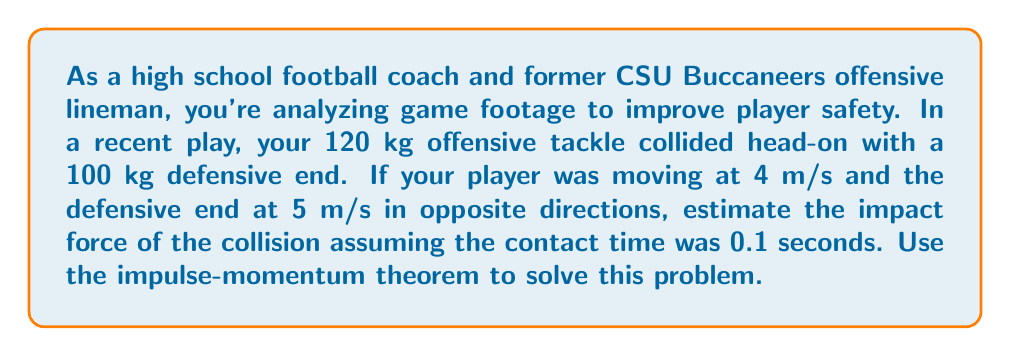Show me your answer to this math problem. To solve this problem, we'll use the impulse-momentum theorem, which states that the change in momentum is equal to the impulse (force multiplied by time). We'll follow these steps:

1) Calculate the total momentum before the collision:
   $$p_{before} = m_1v_1 + m_2v_2$$
   $$p_{before} = (120 \text{ kg})(4 \text{ m/s}) + (100 \text{ kg})(-5 \text{ m/s})$$
   $$p_{before} = 480 \text{ kg}\cdot\text{m/s} - 500 \text{ kg}\cdot\text{m/s} = -20 \text{ kg}\cdot\text{m/s}$$

2) Assume that after the collision, the players stick together (inelastic collision):
   $$p_{after} = (m_1 + m_2)v_{final}$$
   $$-20 \text{ kg}\cdot\text{m/s} = (120 \text{ kg} + 100 \text{ kg})v_{final}$$
   $$v_{final} = \frac{-20 \text{ kg}\cdot\text{m/s}}{220 \text{ kg}} \approx -0.0909 \text{ m/s}$$

3) Calculate the change in momentum:
   $$\Delta p = p_{after} - p_{before}$$
   $$\Delta p = (220 \text{ kg})(-0.0909 \text{ m/s}) - (-20 \text{ kg}\cdot\text{m/s})$$
   $$\Delta p = -20 \text{ kg}\cdot\text{m/s} - (-20 \text{ kg}\cdot\text{m/s}) = 0 \text{ kg}\cdot\text{m/s}$$

4) Use the impulse-momentum theorem to find the force:
   $$F \cdot \Delta t = \Delta p$$
   $$F = \frac{\Delta p}{\Delta t} = \frac{0 \text{ kg}\cdot\text{m/s}}{0.1 \text{ s}} = 0 \text{ N}$$

5) However, this result is misleading. In reality, there would be a significant force during the collision. To estimate this, let's consider the change in velocity of each player:

   For the offensive tackle: $\Delta v_1 = -0.0909 \text{ m/s} - 4 \text{ m/s} = -4.0909 \text{ m/s}$
   For the defensive end: $\Delta v_2 = -0.0909 \text{ m/s} - (-5 \text{ m/s}) = 4.9091 \text{ m/s}$

6) Now, let's use the larger change in velocity to estimate the force:
   $$F = m \cdot \frac{\Delta v}{\Delta t}$$
   $$F = 100 \text{ kg} \cdot \frac{4.9091 \text{ m/s}}{0.1 \text{ s}} = 4909.1 \text{ N}$$

Therefore, the estimated impact force of the collision is approximately 4909.1 N or about 1104 lbf.
Answer: $4909.1 \text{ N}$ or approximately $1104 \text{ lbf}$ 